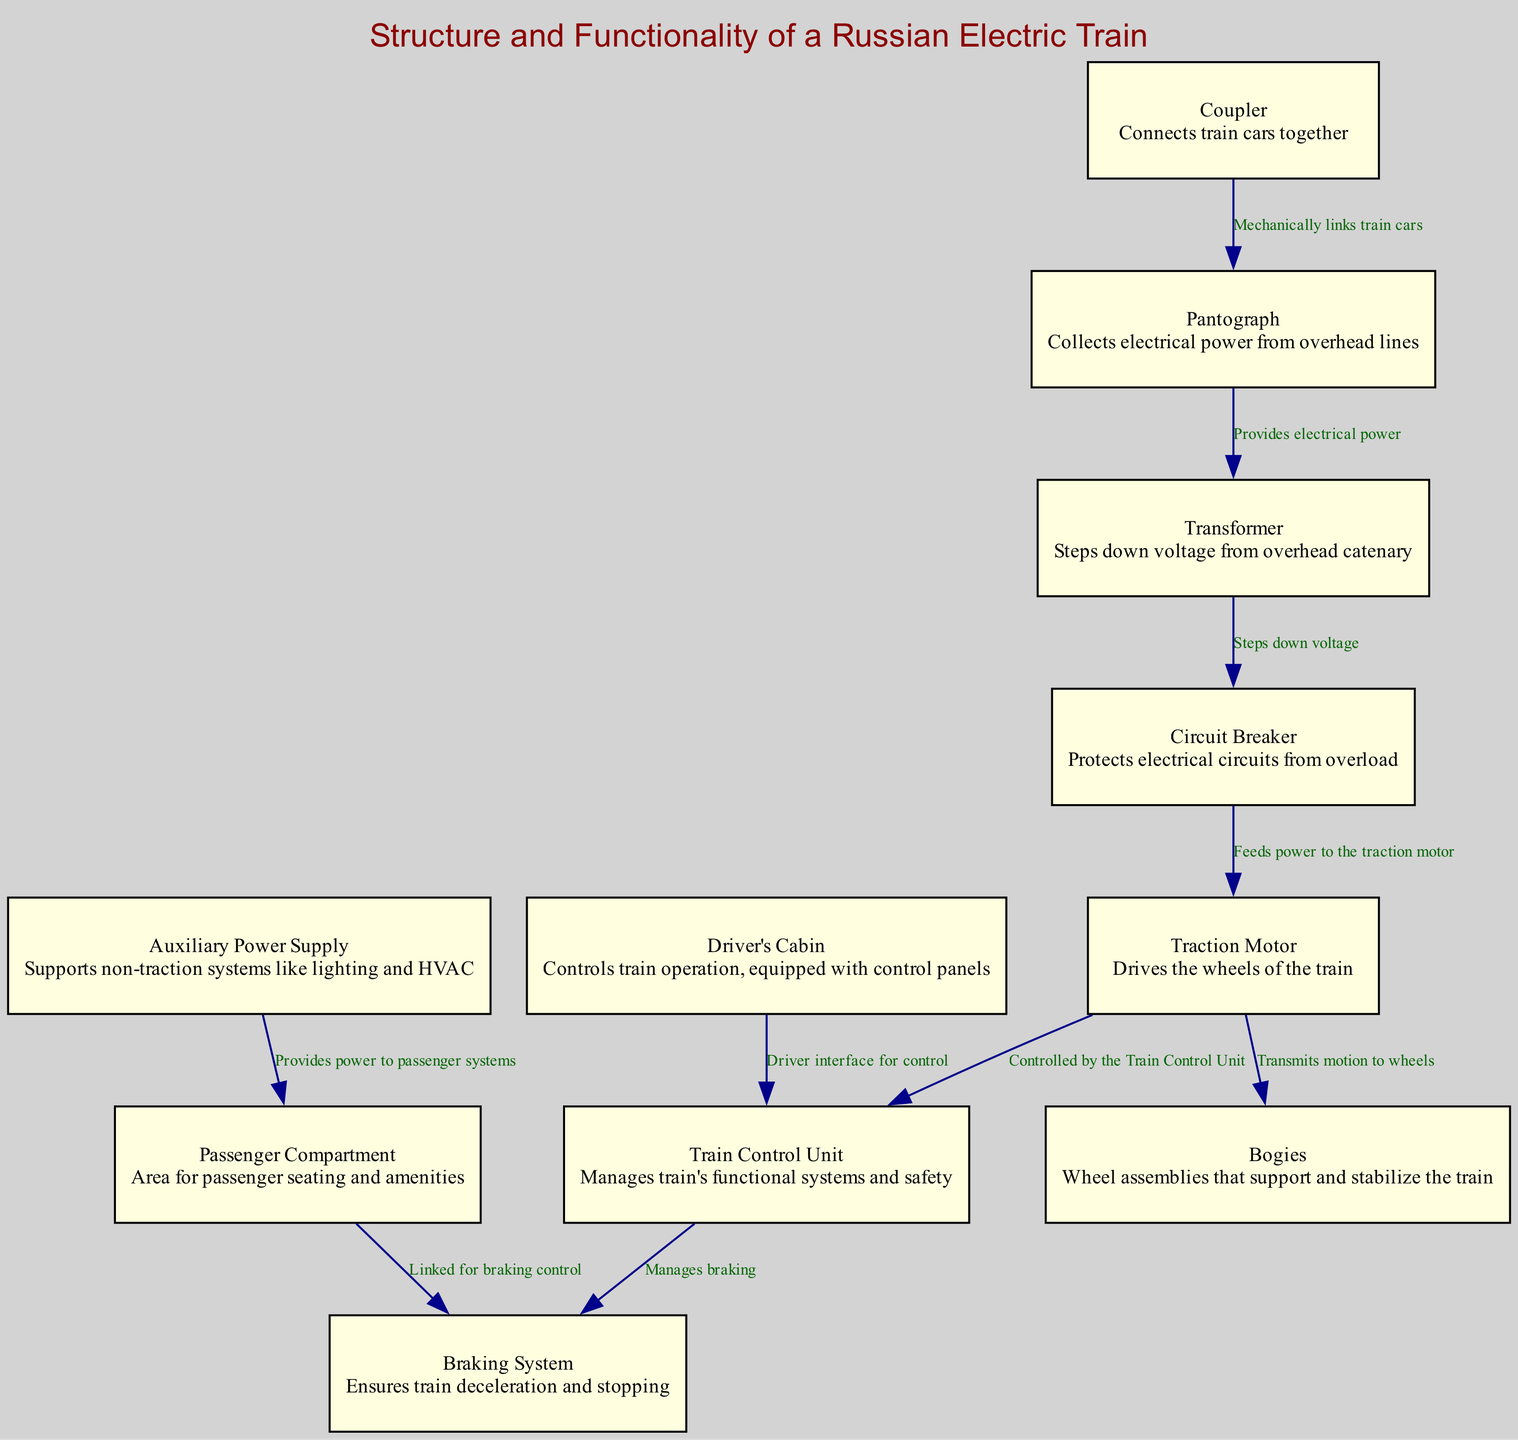What is the primary function of the pantograph? The pantograph collects electrical power from overhead lines, as described in the node's information. It is directly responsible for powering the train, hence its primary function is to gather electricity.
Answer: Collects electrical power from overhead lines How many nodes are represented in the diagram? The diagram includes a total of eleven nodes, each representing a key component or system of the electric train. This number can be confirmed by counting the nodes listed in the data.
Answer: 11 Which component is responsible for managing the train's functional systems? The Train Control Unit is identified in the diagram as the component that manages the train's functional systems and safety. This is clearly labeled in its corresponding node.
Answer: Train Control Unit What is the relationship between the circuit breaker and the traction motor? The circuit breaker feeds power to the traction motor, meaning that it plays a critical role in ensuring the motor receives electricity without overload. This relationship is indicated by the edge connecting these two nodes.
Answer: Feeds power to traction motor Which system supports non-traction systems like lighting and HVAC? The Auxiliary Power Supply is explicitly mentioned as the system that supports non-traction systems, making it clear for anyone studying the components of the train.
Answer: Auxiliary Power Supply How does the driver's cabin interact with the train control unit? The driver's cabin serves as the interface for the driver to control the Train Control Unit. This is established by the edge showing the connection from the driver's cabin to the Train Control Unit, symbolizing its control function.
Answer: Driver interface for control What links the train cars together mechanically? The coupler connects the train cars together, as shown in the diagram. This component is critical for maintaining the integrity of the train's structure during operation.
Answer: Coupler Which component is linked to ensure the train's deceleration and stopping? The braking system is linked to the passenger compartment to ensure the deceleration and stopping of the train, as represented in the edge connecting these two components.
Answer: Braking System What key component transmits motion to the wheels? The traction motor is responsible for transmitting motion to the wheels, as seen in the relationship between the traction motor and bogies. This is a critical function for train movement.
Answer: Transmits motion to wheels 